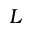<formula> <loc_0><loc_0><loc_500><loc_500>L</formula> 